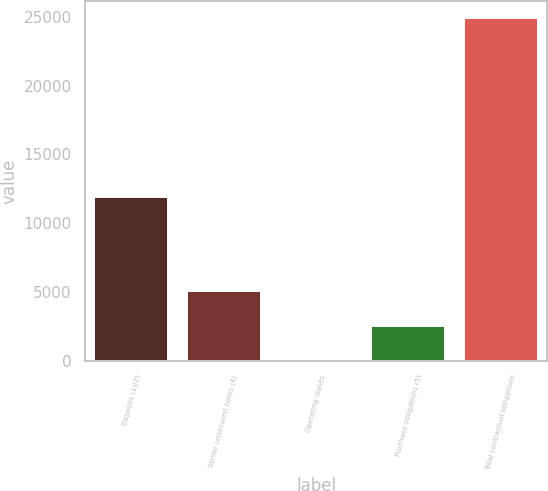Convert chart to OTSL. <chart><loc_0><loc_0><loc_500><loc_500><bar_chart><fcel>Deposits (1)(2)<fcel>Senior unsecured notes (4)<fcel>Operating leases<fcel>Purchase obligations (5)<fcel>Total contractual obligations<nl><fcel>11943<fcel>5049.8<fcel>81<fcel>2565.4<fcel>24925<nl></chart> 